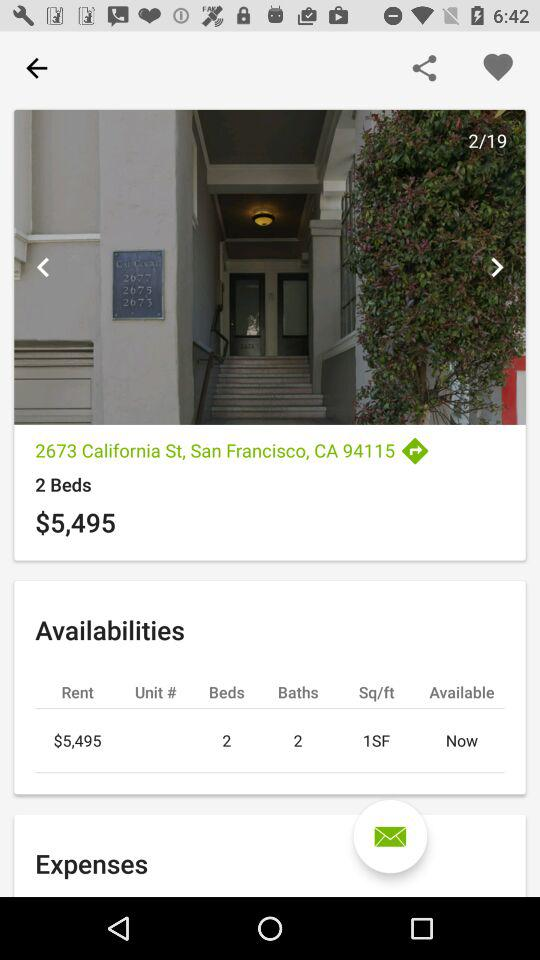How many bedrooms does the unit have?
Answer the question using a single word or phrase. 2 